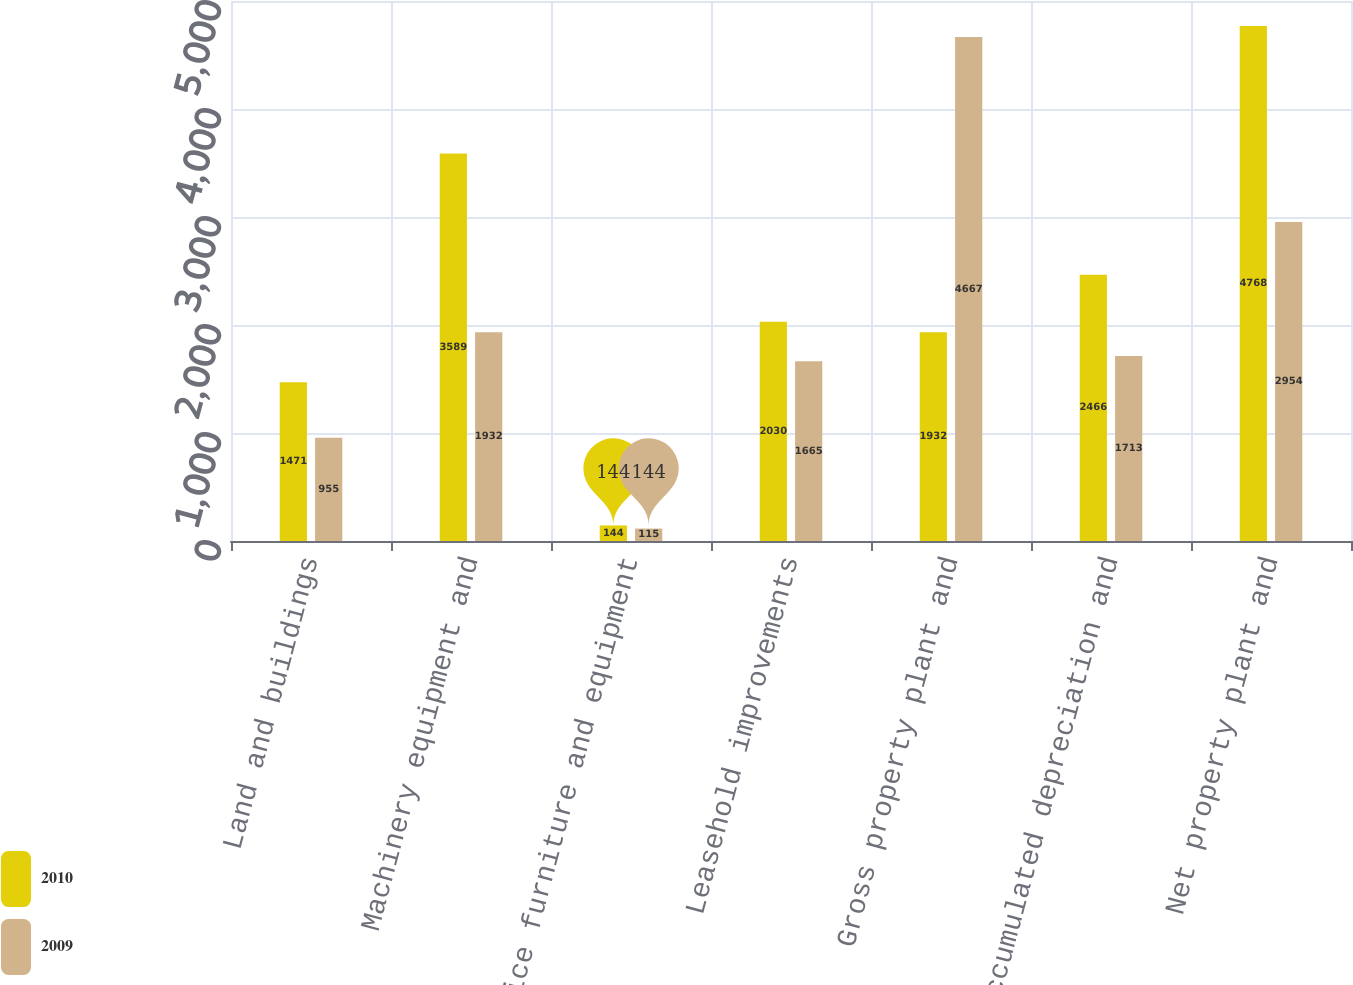Convert chart. <chart><loc_0><loc_0><loc_500><loc_500><stacked_bar_chart><ecel><fcel>Land and buildings<fcel>Machinery equipment and<fcel>Office furniture and equipment<fcel>Leasehold improvements<fcel>Gross property plant and<fcel>Accumulated depreciation and<fcel>Net property plant and<nl><fcel>2010<fcel>1471<fcel>3589<fcel>144<fcel>2030<fcel>1932<fcel>2466<fcel>4768<nl><fcel>2009<fcel>955<fcel>1932<fcel>115<fcel>1665<fcel>4667<fcel>1713<fcel>2954<nl></chart> 